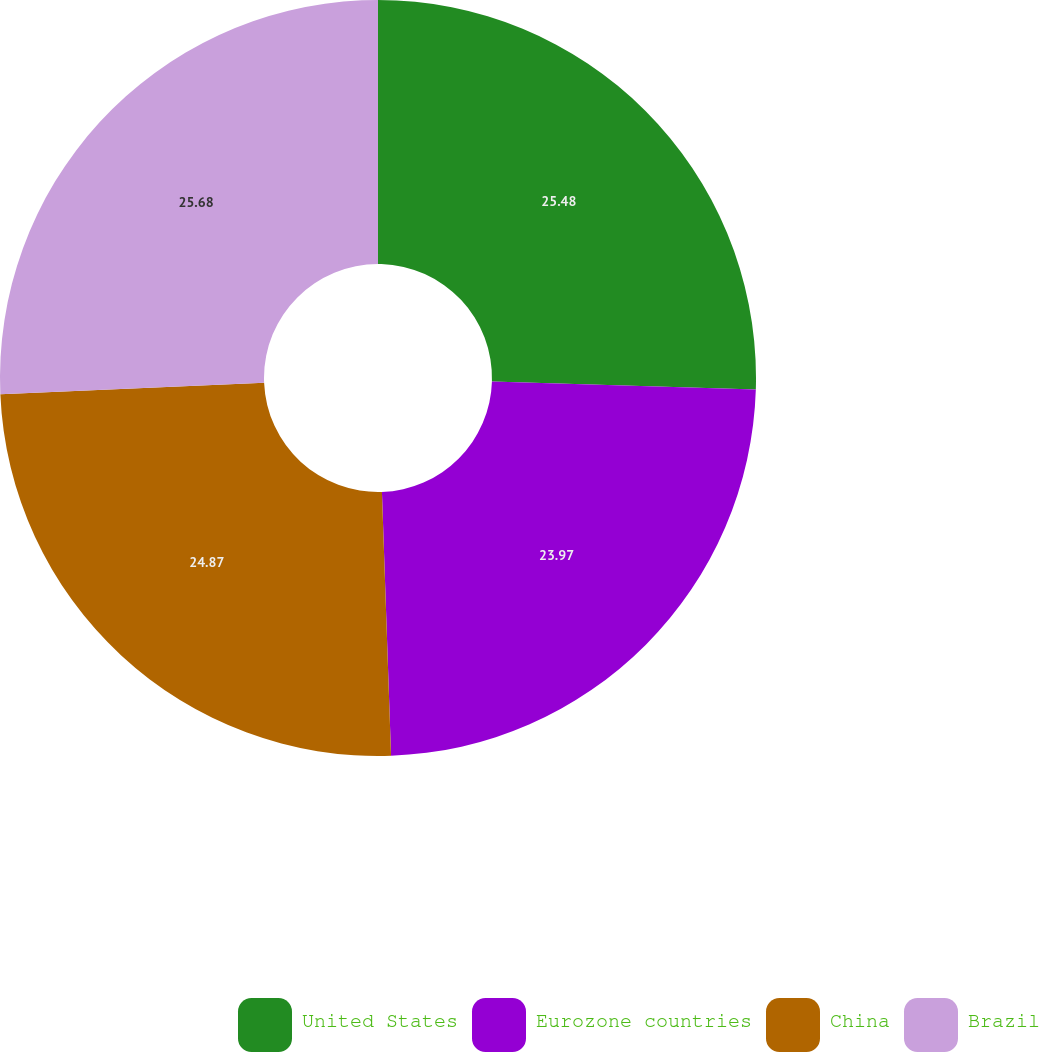Convert chart to OTSL. <chart><loc_0><loc_0><loc_500><loc_500><pie_chart><fcel>United States<fcel>Eurozone countries<fcel>China<fcel>Brazil<nl><fcel>25.48%<fcel>23.97%<fcel>24.87%<fcel>25.68%<nl></chart> 